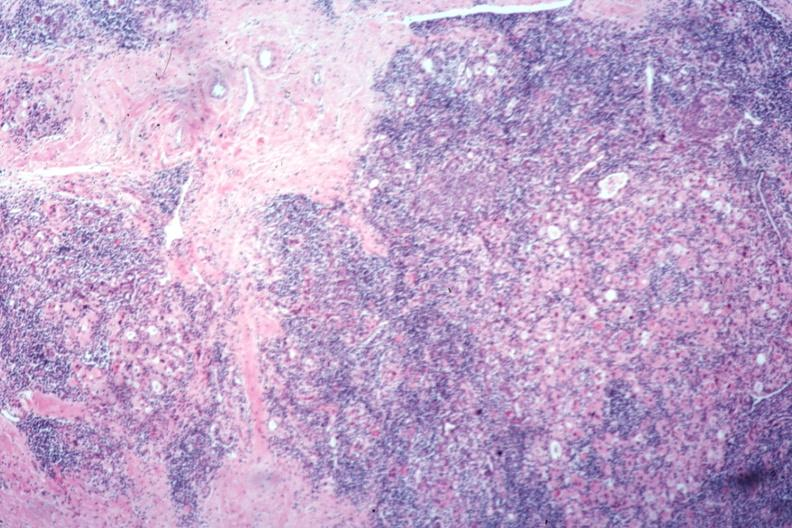s endocrine present?
Answer the question using a single word or phrase. Yes 